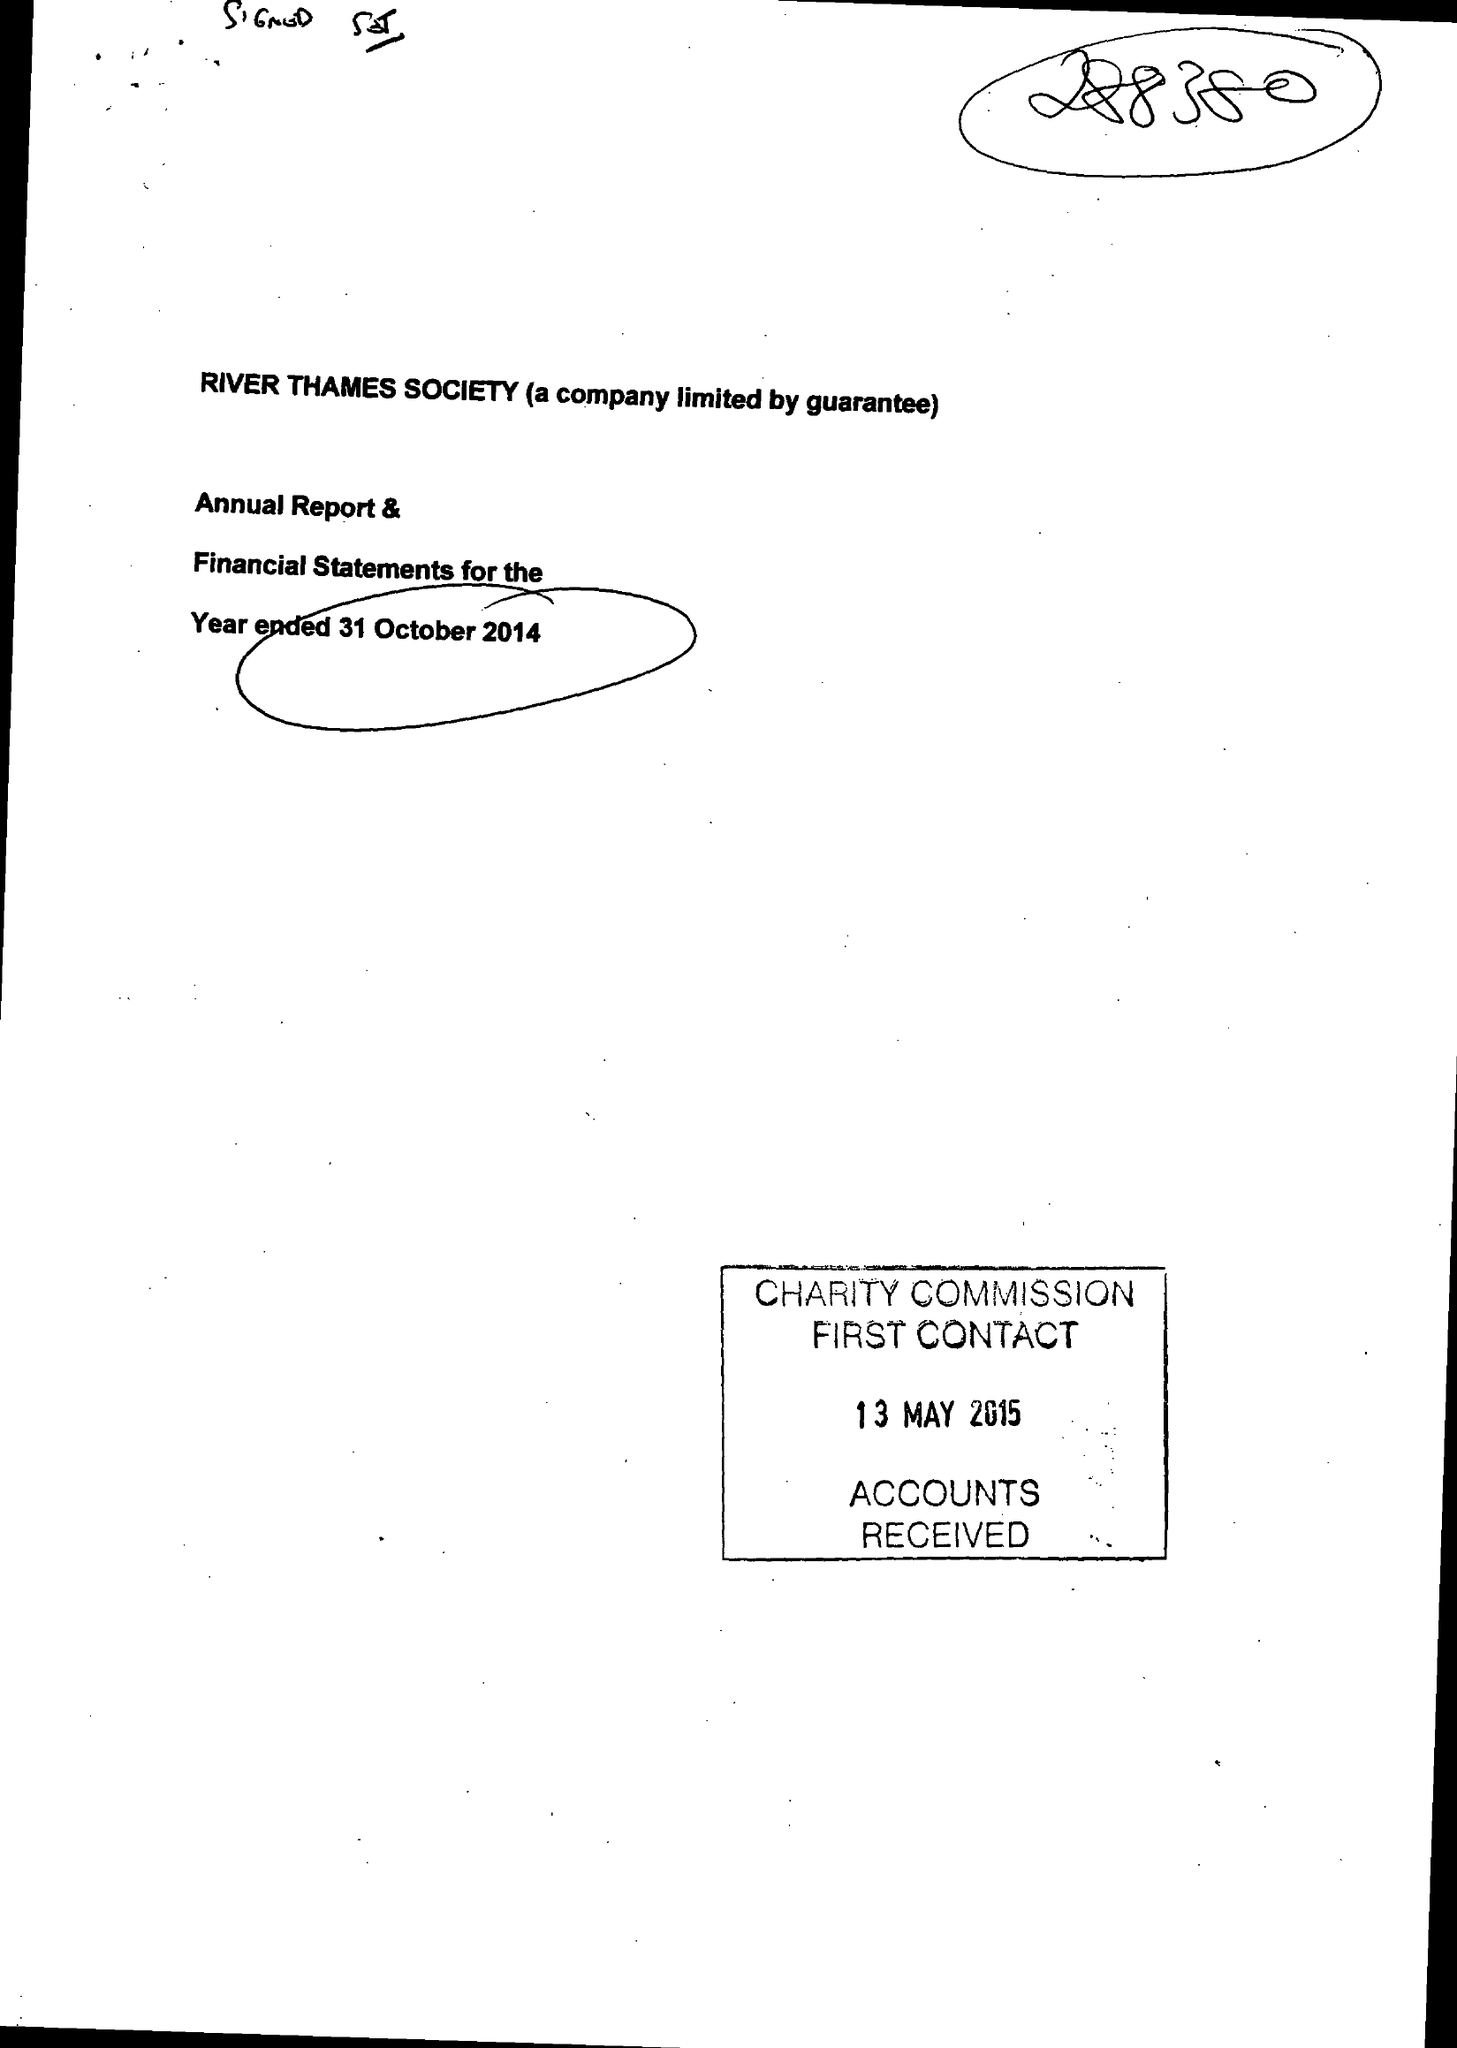What is the value for the charity_name?
Answer the question using a single word or phrase. River Thames Society 